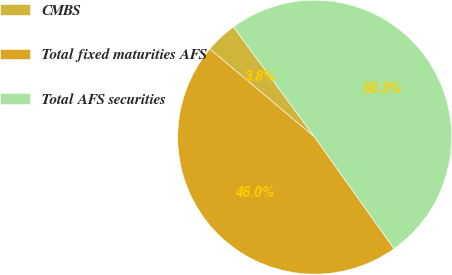Convert chart to OTSL. <chart><loc_0><loc_0><loc_500><loc_500><pie_chart><fcel>CMBS<fcel>Total fixed maturities AFS<fcel>Total AFS securities<nl><fcel>3.77%<fcel>45.97%<fcel>50.26%<nl></chart> 